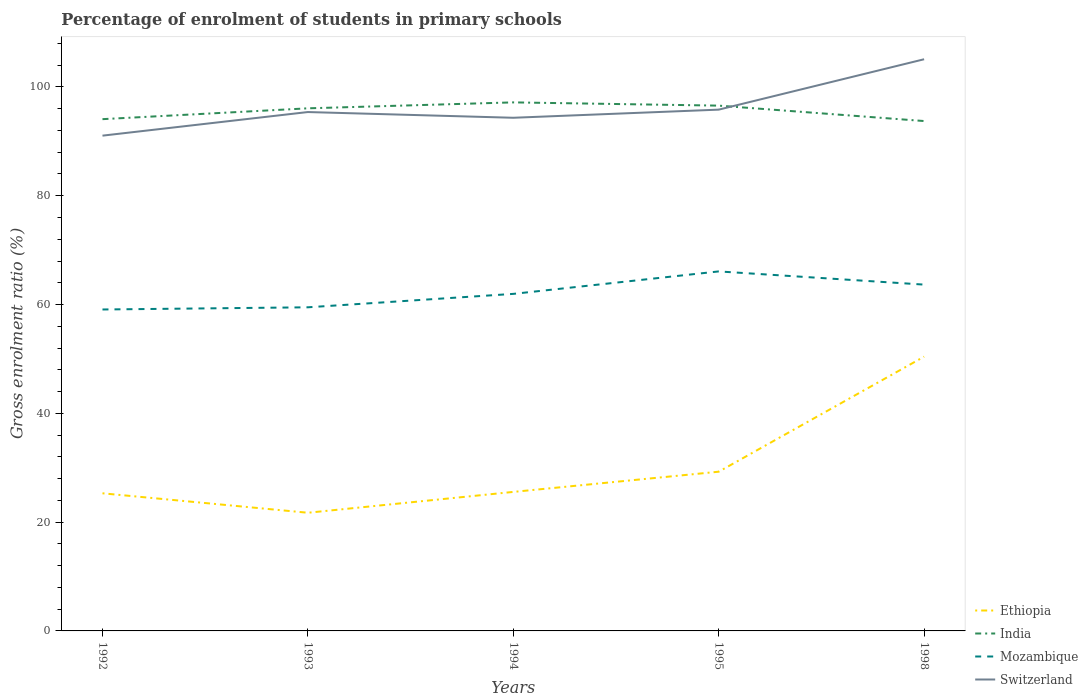How many different coloured lines are there?
Provide a short and direct response. 4. Does the line corresponding to Ethiopia intersect with the line corresponding to Mozambique?
Your response must be concise. No. Across all years, what is the maximum percentage of students enrolled in primary schools in Switzerland?
Offer a very short reply. 91.04. In which year was the percentage of students enrolled in primary schools in Mozambique maximum?
Your response must be concise. 1992. What is the total percentage of students enrolled in primary schools in Mozambique in the graph?
Give a very brief answer. -4.13. What is the difference between the highest and the second highest percentage of students enrolled in primary schools in Mozambique?
Your answer should be compact. 7. How many years are there in the graph?
Your response must be concise. 5. Are the values on the major ticks of Y-axis written in scientific E-notation?
Ensure brevity in your answer.  No. How many legend labels are there?
Your answer should be very brief. 4. How are the legend labels stacked?
Offer a terse response. Vertical. What is the title of the graph?
Your response must be concise. Percentage of enrolment of students in primary schools. Does "Cayman Islands" appear as one of the legend labels in the graph?
Offer a very short reply. No. What is the label or title of the Y-axis?
Provide a short and direct response. Gross enrolment ratio (%). What is the Gross enrolment ratio (%) in Ethiopia in 1992?
Give a very brief answer. 25.3. What is the Gross enrolment ratio (%) in India in 1992?
Give a very brief answer. 94.08. What is the Gross enrolment ratio (%) in Mozambique in 1992?
Keep it short and to the point. 59.09. What is the Gross enrolment ratio (%) in Switzerland in 1992?
Make the answer very short. 91.04. What is the Gross enrolment ratio (%) in Ethiopia in 1993?
Provide a succinct answer. 21.72. What is the Gross enrolment ratio (%) in India in 1993?
Your response must be concise. 96.07. What is the Gross enrolment ratio (%) in Mozambique in 1993?
Your answer should be very brief. 59.49. What is the Gross enrolment ratio (%) in Switzerland in 1993?
Provide a succinct answer. 95.38. What is the Gross enrolment ratio (%) of Ethiopia in 1994?
Provide a short and direct response. 25.55. What is the Gross enrolment ratio (%) of India in 1994?
Make the answer very short. 97.16. What is the Gross enrolment ratio (%) in Mozambique in 1994?
Provide a short and direct response. 61.96. What is the Gross enrolment ratio (%) of Switzerland in 1994?
Provide a succinct answer. 94.33. What is the Gross enrolment ratio (%) of Ethiopia in 1995?
Offer a very short reply. 29.27. What is the Gross enrolment ratio (%) in India in 1995?
Provide a short and direct response. 96.56. What is the Gross enrolment ratio (%) of Mozambique in 1995?
Your answer should be compact. 66.09. What is the Gross enrolment ratio (%) in Switzerland in 1995?
Provide a succinct answer. 95.83. What is the Gross enrolment ratio (%) of Ethiopia in 1998?
Provide a short and direct response. 50.42. What is the Gross enrolment ratio (%) of India in 1998?
Ensure brevity in your answer.  93.73. What is the Gross enrolment ratio (%) in Mozambique in 1998?
Ensure brevity in your answer.  63.66. What is the Gross enrolment ratio (%) of Switzerland in 1998?
Your answer should be compact. 105.09. Across all years, what is the maximum Gross enrolment ratio (%) of Ethiopia?
Your answer should be compact. 50.42. Across all years, what is the maximum Gross enrolment ratio (%) in India?
Give a very brief answer. 97.16. Across all years, what is the maximum Gross enrolment ratio (%) of Mozambique?
Your response must be concise. 66.09. Across all years, what is the maximum Gross enrolment ratio (%) of Switzerland?
Provide a short and direct response. 105.09. Across all years, what is the minimum Gross enrolment ratio (%) in Ethiopia?
Your answer should be compact. 21.72. Across all years, what is the minimum Gross enrolment ratio (%) in India?
Make the answer very short. 93.73. Across all years, what is the minimum Gross enrolment ratio (%) of Mozambique?
Make the answer very short. 59.09. Across all years, what is the minimum Gross enrolment ratio (%) in Switzerland?
Offer a very short reply. 91.04. What is the total Gross enrolment ratio (%) in Ethiopia in the graph?
Ensure brevity in your answer.  152.26. What is the total Gross enrolment ratio (%) of India in the graph?
Keep it short and to the point. 477.59. What is the total Gross enrolment ratio (%) of Mozambique in the graph?
Offer a terse response. 310.28. What is the total Gross enrolment ratio (%) of Switzerland in the graph?
Give a very brief answer. 481.67. What is the difference between the Gross enrolment ratio (%) in Ethiopia in 1992 and that in 1993?
Your response must be concise. 3.58. What is the difference between the Gross enrolment ratio (%) of India in 1992 and that in 1993?
Provide a succinct answer. -1.99. What is the difference between the Gross enrolment ratio (%) in Mozambique in 1992 and that in 1993?
Your answer should be compact. -0.4. What is the difference between the Gross enrolment ratio (%) in Switzerland in 1992 and that in 1993?
Keep it short and to the point. -4.34. What is the difference between the Gross enrolment ratio (%) of Ethiopia in 1992 and that in 1994?
Give a very brief answer. -0.26. What is the difference between the Gross enrolment ratio (%) in India in 1992 and that in 1994?
Keep it short and to the point. -3.08. What is the difference between the Gross enrolment ratio (%) in Mozambique in 1992 and that in 1994?
Provide a succinct answer. -2.87. What is the difference between the Gross enrolment ratio (%) of Switzerland in 1992 and that in 1994?
Make the answer very short. -3.29. What is the difference between the Gross enrolment ratio (%) of Ethiopia in 1992 and that in 1995?
Provide a succinct answer. -3.97. What is the difference between the Gross enrolment ratio (%) in India in 1992 and that in 1995?
Ensure brevity in your answer.  -2.49. What is the difference between the Gross enrolment ratio (%) in Mozambique in 1992 and that in 1995?
Ensure brevity in your answer.  -7. What is the difference between the Gross enrolment ratio (%) in Switzerland in 1992 and that in 1995?
Ensure brevity in your answer.  -4.78. What is the difference between the Gross enrolment ratio (%) of Ethiopia in 1992 and that in 1998?
Ensure brevity in your answer.  -25.12. What is the difference between the Gross enrolment ratio (%) of India in 1992 and that in 1998?
Make the answer very short. 0.35. What is the difference between the Gross enrolment ratio (%) in Mozambique in 1992 and that in 1998?
Ensure brevity in your answer.  -4.57. What is the difference between the Gross enrolment ratio (%) of Switzerland in 1992 and that in 1998?
Your response must be concise. -14.04. What is the difference between the Gross enrolment ratio (%) of Ethiopia in 1993 and that in 1994?
Offer a very short reply. -3.83. What is the difference between the Gross enrolment ratio (%) of India in 1993 and that in 1994?
Offer a very short reply. -1.09. What is the difference between the Gross enrolment ratio (%) in Mozambique in 1993 and that in 1994?
Provide a short and direct response. -2.47. What is the difference between the Gross enrolment ratio (%) of Switzerland in 1993 and that in 1994?
Offer a very short reply. 1.05. What is the difference between the Gross enrolment ratio (%) in Ethiopia in 1993 and that in 1995?
Make the answer very short. -7.55. What is the difference between the Gross enrolment ratio (%) in India in 1993 and that in 1995?
Provide a succinct answer. -0.5. What is the difference between the Gross enrolment ratio (%) of Mozambique in 1993 and that in 1995?
Your response must be concise. -6.6. What is the difference between the Gross enrolment ratio (%) of Switzerland in 1993 and that in 1995?
Offer a very short reply. -0.44. What is the difference between the Gross enrolment ratio (%) of Ethiopia in 1993 and that in 1998?
Provide a short and direct response. -28.7. What is the difference between the Gross enrolment ratio (%) of India in 1993 and that in 1998?
Give a very brief answer. 2.34. What is the difference between the Gross enrolment ratio (%) of Mozambique in 1993 and that in 1998?
Give a very brief answer. -4.17. What is the difference between the Gross enrolment ratio (%) in Switzerland in 1993 and that in 1998?
Ensure brevity in your answer.  -9.7. What is the difference between the Gross enrolment ratio (%) of Ethiopia in 1994 and that in 1995?
Your response must be concise. -3.71. What is the difference between the Gross enrolment ratio (%) in India in 1994 and that in 1995?
Make the answer very short. 0.6. What is the difference between the Gross enrolment ratio (%) in Mozambique in 1994 and that in 1995?
Your answer should be compact. -4.13. What is the difference between the Gross enrolment ratio (%) of Switzerland in 1994 and that in 1995?
Your response must be concise. -1.49. What is the difference between the Gross enrolment ratio (%) in Ethiopia in 1994 and that in 1998?
Keep it short and to the point. -24.86. What is the difference between the Gross enrolment ratio (%) of India in 1994 and that in 1998?
Your answer should be compact. 3.43. What is the difference between the Gross enrolment ratio (%) of Mozambique in 1994 and that in 1998?
Make the answer very short. -1.7. What is the difference between the Gross enrolment ratio (%) of Switzerland in 1994 and that in 1998?
Provide a succinct answer. -10.76. What is the difference between the Gross enrolment ratio (%) of Ethiopia in 1995 and that in 1998?
Provide a short and direct response. -21.15. What is the difference between the Gross enrolment ratio (%) of India in 1995 and that in 1998?
Offer a terse response. 2.83. What is the difference between the Gross enrolment ratio (%) in Mozambique in 1995 and that in 1998?
Your answer should be very brief. 2.43. What is the difference between the Gross enrolment ratio (%) of Switzerland in 1995 and that in 1998?
Ensure brevity in your answer.  -9.26. What is the difference between the Gross enrolment ratio (%) of Ethiopia in 1992 and the Gross enrolment ratio (%) of India in 1993?
Provide a short and direct response. -70.77. What is the difference between the Gross enrolment ratio (%) of Ethiopia in 1992 and the Gross enrolment ratio (%) of Mozambique in 1993?
Provide a succinct answer. -34.19. What is the difference between the Gross enrolment ratio (%) of Ethiopia in 1992 and the Gross enrolment ratio (%) of Switzerland in 1993?
Your answer should be compact. -70.08. What is the difference between the Gross enrolment ratio (%) of India in 1992 and the Gross enrolment ratio (%) of Mozambique in 1993?
Make the answer very short. 34.59. What is the difference between the Gross enrolment ratio (%) of India in 1992 and the Gross enrolment ratio (%) of Switzerland in 1993?
Your answer should be compact. -1.31. What is the difference between the Gross enrolment ratio (%) in Mozambique in 1992 and the Gross enrolment ratio (%) in Switzerland in 1993?
Your answer should be compact. -36.3. What is the difference between the Gross enrolment ratio (%) of Ethiopia in 1992 and the Gross enrolment ratio (%) of India in 1994?
Your response must be concise. -71.86. What is the difference between the Gross enrolment ratio (%) of Ethiopia in 1992 and the Gross enrolment ratio (%) of Mozambique in 1994?
Offer a very short reply. -36.66. What is the difference between the Gross enrolment ratio (%) in Ethiopia in 1992 and the Gross enrolment ratio (%) in Switzerland in 1994?
Provide a short and direct response. -69.03. What is the difference between the Gross enrolment ratio (%) of India in 1992 and the Gross enrolment ratio (%) of Mozambique in 1994?
Your answer should be very brief. 32.12. What is the difference between the Gross enrolment ratio (%) of India in 1992 and the Gross enrolment ratio (%) of Switzerland in 1994?
Give a very brief answer. -0.26. What is the difference between the Gross enrolment ratio (%) of Mozambique in 1992 and the Gross enrolment ratio (%) of Switzerland in 1994?
Offer a terse response. -35.24. What is the difference between the Gross enrolment ratio (%) of Ethiopia in 1992 and the Gross enrolment ratio (%) of India in 1995?
Offer a very short reply. -71.26. What is the difference between the Gross enrolment ratio (%) in Ethiopia in 1992 and the Gross enrolment ratio (%) in Mozambique in 1995?
Offer a very short reply. -40.79. What is the difference between the Gross enrolment ratio (%) of Ethiopia in 1992 and the Gross enrolment ratio (%) of Switzerland in 1995?
Keep it short and to the point. -70.53. What is the difference between the Gross enrolment ratio (%) in India in 1992 and the Gross enrolment ratio (%) in Mozambique in 1995?
Your answer should be very brief. 27.99. What is the difference between the Gross enrolment ratio (%) of India in 1992 and the Gross enrolment ratio (%) of Switzerland in 1995?
Your response must be concise. -1.75. What is the difference between the Gross enrolment ratio (%) of Mozambique in 1992 and the Gross enrolment ratio (%) of Switzerland in 1995?
Your answer should be very brief. -36.74. What is the difference between the Gross enrolment ratio (%) of Ethiopia in 1992 and the Gross enrolment ratio (%) of India in 1998?
Provide a short and direct response. -68.43. What is the difference between the Gross enrolment ratio (%) of Ethiopia in 1992 and the Gross enrolment ratio (%) of Mozambique in 1998?
Give a very brief answer. -38.36. What is the difference between the Gross enrolment ratio (%) in Ethiopia in 1992 and the Gross enrolment ratio (%) in Switzerland in 1998?
Make the answer very short. -79.79. What is the difference between the Gross enrolment ratio (%) in India in 1992 and the Gross enrolment ratio (%) in Mozambique in 1998?
Your response must be concise. 30.42. What is the difference between the Gross enrolment ratio (%) of India in 1992 and the Gross enrolment ratio (%) of Switzerland in 1998?
Give a very brief answer. -11.01. What is the difference between the Gross enrolment ratio (%) in Mozambique in 1992 and the Gross enrolment ratio (%) in Switzerland in 1998?
Provide a short and direct response. -46. What is the difference between the Gross enrolment ratio (%) of Ethiopia in 1993 and the Gross enrolment ratio (%) of India in 1994?
Give a very brief answer. -75.44. What is the difference between the Gross enrolment ratio (%) of Ethiopia in 1993 and the Gross enrolment ratio (%) of Mozambique in 1994?
Provide a succinct answer. -40.23. What is the difference between the Gross enrolment ratio (%) of Ethiopia in 1993 and the Gross enrolment ratio (%) of Switzerland in 1994?
Your response must be concise. -72.61. What is the difference between the Gross enrolment ratio (%) in India in 1993 and the Gross enrolment ratio (%) in Mozambique in 1994?
Your answer should be compact. 34.11. What is the difference between the Gross enrolment ratio (%) of India in 1993 and the Gross enrolment ratio (%) of Switzerland in 1994?
Provide a succinct answer. 1.73. What is the difference between the Gross enrolment ratio (%) of Mozambique in 1993 and the Gross enrolment ratio (%) of Switzerland in 1994?
Offer a terse response. -34.84. What is the difference between the Gross enrolment ratio (%) of Ethiopia in 1993 and the Gross enrolment ratio (%) of India in 1995?
Your answer should be compact. -74.84. What is the difference between the Gross enrolment ratio (%) in Ethiopia in 1993 and the Gross enrolment ratio (%) in Mozambique in 1995?
Ensure brevity in your answer.  -44.36. What is the difference between the Gross enrolment ratio (%) of Ethiopia in 1993 and the Gross enrolment ratio (%) of Switzerland in 1995?
Make the answer very short. -74.1. What is the difference between the Gross enrolment ratio (%) of India in 1993 and the Gross enrolment ratio (%) of Mozambique in 1995?
Provide a succinct answer. 29.98. What is the difference between the Gross enrolment ratio (%) in India in 1993 and the Gross enrolment ratio (%) in Switzerland in 1995?
Keep it short and to the point. 0.24. What is the difference between the Gross enrolment ratio (%) of Mozambique in 1993 and the Gross enrolment ratio (%) of Switzerland in 1995?
Make the answer very short. -36.34. What is the difference between the Gross enrolment ratio (%) of Ethiopia in 1993 and the Gross enrolment ratio (%) of India in 1998?
Provide a short and direct response. -72.01. What is the difference between the Gross enrolment ratio (%) in Ethiopia in 1993 and the Gross enrolment ratio (%) in Mozambique in 1998?
Provide a short and direct response. -41.94. What is the difference between the Gross enrolment ratio (%) in Ethiopia in 1993 and the Gross enrolment ratio (%) in Switzerland in 1998?
Offer a very short reply. -83.37. What is the difference between the Gross enrolment ratio (%) of India in 1993 and the Gross enrolment ratio (%) of Mozambique in 1998?
Offer a very short reply. 32.41. What is the difference between the Gross enrolment ratio (%) in India in 1993 and the Gross enrolment ratio (%) in Switzerland in 1998?
Provide a succinct answer. -9.02. What is the difference between the Gross enrolment ratio (%) of Mozambique in 1993 and the Gross enrolment ratio (%) of Switzerland in 1998?
Your answer should be very brief. -45.6. What is the difference between the Gross enrolment ratio (%) of Ethiopia in 1994 and the Gross enrolment ratio (%) of India in 1995?
Provide a short and direct response. -71.01. What is the difference between the Gross enrolment ratio (%) in Ethiopia in 1994 and the Gross enrolment ratio (%) in Mozambique in 1995?
Make the answer very short. -40.53. What is the difference between the Gross enrolment ratio (%) in Ethiopia in 1994 and the Gross enrolment ratio (%) in Switzerland in 1995?
Keep it short and to the point. -70.27. What is the difference between the Gross enrolment ratio (%) of India in 1994 and the Gross enrolment ratio (%) of Mozambique in 1995?
Provide a short and direct response. 31.07. What is the difference between the Gross enrolment ratio (%) in India in 1994 and the Gross enrolment ratio (%) in Switzerland in 1995?
Give a very brief answer. 1.33. What is the difference between the Gross enrolment ratio (%) of Mozambique in 1994 and the Gross enrolment ratio (%) of Switzerland in 1995?
Give a very brief answer. -33.87. What is the difference between the Gross enrolment ratio (%) in Ethiopia in 1994 and the Gross enrolment ratio (%) in India in 1998?
Give a very brief answer. -68.17. What is the difference between the Gross enrolment ratio (%) of Ethiopia in 1994 and the Gross enrolment ratio (%) of Mozambique in 1998?
Your answer should be very brief. -38.11. What is the difference between the Gross enrolment ratio (%) of Ethiopia in 1994 and the Gross enrolment ratio (%) of Switzerland in 1998?
Offer a terse response. -79.53. What is the difference between the Gross enrolment ratio (%) in India in 1994 and the Gross enrolment ratio (%) in Mozambique in 1998?
Make the answer very short. 33.5. What is the difference between the Gross enrolment ratio (%) in India in 1994 and the Gross enrolment ratio (%) in Switzerland in 1998?
Provide a short and direct response. -7.93. What is the difference between the Gross enrolment ratio (%) in Mozambique in 1994 and the Gross enrolment ratio (%) in Switzerland in 1998?
Provide a short and direct response. -43.13. What is the difference between the Gross enrolment ratio (%) of Ethiopia in 1995 and the Gross enrolment ratio (%) of India in 1998?
Give a very brief answer. -64.46. What is the difference between the Gross enrolment ratio (%) in Ethiopia in 1995 and the Gross enrolment ratio (%) in Mozambique in 1998?
Offer a very short reply. -34.39. What is the difference between the Gross enrolment ratio (%) in Ethiopia in 1995 and the Gross enrolment ratio (%) in Switzerland in 1998?
Provide a succinct answer. -75.82. What is the difference between the Gross enrolment ratio (%) of India in 1995 and the Gross enrolment ratio (%) of Mozambique in 1998?
Keep it short and to the point. 32.9. What is the difference between the Gross enrolment ratio (%) in India in 1995 and the Gross enrolment ratio (%) in Switzerland in 1998?
Ensure brevity in your answer.  -8.53. What is the difference between the Gross enrolment ratio (%) in Mozambique in 1995 and the Gross enrolment ratio (%) in Switzerland in 1998?
Your answer should be very brief. -39. What is the average Gross enrolment ratio (%) of Ethiopia per year?
Make the answer very short. 30.45. What is the average Gross enrolment ratio (%) in India per year?
Your answer should be very brief. 95.52. What is the average Gross enrolment ratio (%) in Mozambique per year?
Your answer should be compact. 62.06. What is the average Gross enrolment ratio (%) in Switzerland per year?
Provide a short and direct response. 96.33. In the year 1992, what is the difference between the Gross enrolment ratio (%) in Ethiopia and Gross enrolment ratio (%) in India?
Offer a terse response. -68.78. In the year 1992, what is the difference between the Gross enrolment ratio (%) of Ethiopia and Gross enrolment ratio (%) of Mozambique?
Your answer should be very brief. -33.79. In the year 1992, what is the difference between the Gross enrolment ratio (%) of Ethiopia and Gross enrolment ratio (%) of Switzerland?
Your response must be concise. -65.74. In the year 1992, what is the difference between the Gross enrolment ratio (%) of India and Gross enrolment ratio (%) of Mozambique?
Give a very brief answer. 34.99. In the year 1992, what is the difference between the Gross enrolment ratio (%) in India and Gross enrolment ratio (%) in Switzerland?
Your answer should be very brief. 3.03. In the year 1992, what is the difference between the Gross enrolment ratio (%) in Mozambique and Gross enrolment ratio (%) in Switzerland?
Ensure brevity in your answer.  -31.96. In the year 1993, what is the difference between the Gross enrolment ratio (%) in Ethiopia and Gross enrolment ratio (%) in India?
Give a very brief answer. -74.34. In the year 1993, what is the difference between the Gross enrolment ratio (%) of Ethiopia and Gross enrolment ratio (%) of Mozambique?
Ensure brevity in your answer.  -37.77. In the year 1993, what is the difference between the Gross enrolment ratio (%) of Ethiopia and Gross enrolment ratio (%) of Switzerland?
Offer a terse response. -73.66. In the year 1993, what is the difference between the Gross enrolment ratio (%) of India and Gross enrolment ratio (%) of Mozambique?
Ensure brevity in your answer.  36.58. In the year 1993, what is the difference between the Gross enrolment ratio (%) in India and Gross enrolment ratio (%) in Switzerland?
Offer a terse response. 0.68. In the year 1993, what is the difference between the Gross enrolment ratio (%) in Mozambique and Gross enrolment ratio (%) in Switzerland?
Provide a succinct answer. -35.89. In the year 1994, what is the difference between the Gross enrolment ratio (%) in Ethiopia and Gross enrolment ratio (%) in India?
Your answer should be compact. -71.6. In the year 1994, what is the difference between the Gross enrolment ratio (%) in Ethiopia and Gross enrolment ratio (%) in Mozambique?
Ensure brevity in your answer.  -36.4. In the year 1994, what is the difference between the Gross enrolment ratio (%) of Ethiopia and Gross enrolment ratio (%) of Switzerland?
Provide a succinct answer. -68.78. In the year 1994, what is the difference between the Gross enrolment ratio (%) in India and Gross enrolment ratio (%) in Mozambique?
Your answer should be compact. 35.2. In the year 1994, what is the difference between the Gross enrolment ratio (%) in India and Gross enrolment ratio (%) in Switzerland?
Your answer should be compact. 2.83. In the year 1994, what is the difference between the Gross enrolment ratio (%) in Mozambique and Gross enrolment ratio (%) in Switzerland?
Your response must be concise. -32.37. In the year 1995, what is the difference between the Gross enrolment ratio (%) in Ethiopia and Gross enrolment ratio (%) in India?
Your response must be concise. -67.29. In the year 1995, what is the difference between the Gross enrolment ratio (%) in Ethiopia and Gross enrolment ratio (%) in Mozambique?
Provide a succinct answer. -36.82. In the year 1995, what is the difference between the Gross enrolment ratio (%) of Ethiopia and Gross enrolment ratio (%) of Switzerland?
Make the answer very short. -66.56. In the year 1995, what is the difference between the Gross enrolment ratio (%) of India and Gross enrolment ratio (%) of Mozambique?
Offer a very short reply. 30.48. In the year 1995, what is the difference between the Gross enrolment ratio (%) of India and Gross enrolment ratio (%) of Switzerland?
Ensure brevity in your answer.  0.74. In the year 1995, what is the difference between the Gross enrolment ratio (%) of Mozambique and Gross enrolment ratio (%) of Switzerland?
Make the answer very short. -29.74. In the year 1998, what is the difference between the Gross enrolment ratio (%) of Ethiopia and Gross enrolment ratio (%) of India?
Keep it short and to the point. -43.31. In the year 1998, what is the difference between the Gross enrolment ratio (%) of Ethiopia and Gross enrolment ratio (%) of Mozambique?
Provide a short and direct response. -13.24. In the year 1998, what is the difference between the Gross enrolment ratio (%) in Ethiopia and Gross enrolment ratio (%) in Switzerland?
Your answer should be very brief. -54.67. In the year 1998, what is the difference between the Gross enrolment ratio (%) of India and Gross enrolment ratio (%) of Mozambique?
Offer a very short reply. 30.07. In the year 1998, what is the difference between the Gross enrolment ratio (%) in India and Gross enrolment ratio (%) in Switzerland?
Your response must be concise. -11.36. In the year 1998, what is the difference between the Gross enrolment ratio (%) in Mozambique and Gross enrolment ratio (%) in Switzerland?
Your answer should be very brief. -41.43. What is the ratio of the Gross enrolment ratio (%) in Ethiopia in 1992 to that in 1993?
Offer a terse response. 1.16. What is the ratio of the Gross enrolment ratio (%) of India in 1992 to that in 1993?
Give a very brief answer. 0.98. What is the ratio of the Gross enrolment ratio (%) of Switzerland in 1992 to that in 1993?
Ensure brevity in your answer.  0.95. What is the ratio of the Gross enrolment ratio (%) in India in 1992 to that in 1994?
Offer a terse response. 0.97. What is the ratio of the Gross enrolment ratio (%) of Mozambique in 1992 to that in 1994?
Provide a short and direct response. 0.95. What is the ratio of the Gross enrolment ratio (%) in Switzerland in 1992 to that in 1994?
Your response must be concise. 0.97. What is the ratio of the Gross enrolment ratio (%) of Ethiopia in 1992 to that in 1995?
Keep it short and to the point. 0.86. What is the ratio of the Gross enrolment ratio (%) in India in 1992 to that in 1995?
Your response must be concise. 0.97. What is the ratio of the Gross enrolment ratio (%) in Mozambique in 1992 to that in 1995?
Keep it short and to the point. 0.89. What is the ratio of the Gross enrolment ratio (%) in Switzerland in 1992 to that in 1995?
Ensure brevity in your answer.  0.95. What is the ratio of the Gross enrolment ratio (%) in Ethiopia in 1992 to that in 1998?
Provide a short and direct response. 0.5. What is the ratio of the Gross enrolment ratio (%) of Mozambique in 1992 to that in 1998?
Your answer should be very brief. 0.93. What is the ratio of the Gross enrolment ratio (%) in Switzerland in 1992 to that in 1998?
Your answer should be very brief. 0.87. What is the ratio of the Gross enrolment ratio (%) in Ethiopia in 1993 to that in 1994?
Provide a short and direct response. 0.85. What is the ratio of the Gross enrolment ratio (%) of Mozambique in 1993 to that in 1994?
Your answer should be compact. 0.96. What is the ratio of the Gross enrolment ratio (%) of Switzerland in 1993 to that in 1994?
Make the answer very short. 1.01. What is the ratio of the Gross enrolment ratio (%) of Ethiopia in 1993 to that in 1995?
Your answer should be very brief. 0.74. What is the ratio of the Gross enrolment ratio (%) in India in 1993 to that in 1995?
Ensure brevity in your answer.  0.99. What is the ratio of the Gross enrolment ratio (%) in Mozambique in 1993 to that in 1995?
Offer a terse response. 0.9. What is the ratio of the Gross enrolment ratio (%) of Switzerland in 1993 to that in 1995?
Offer a terse response. 1. What is the ratio of the Gross enrolment ratio (%) in Ethiopia in 1993 to that in 1998?
Your answer should be compact. 0.43. What is the ratio of the Gross enrolment ratio (%) in India in 1993 to that in 1998?
Your response must be concise. 1.02. What is the ratio of the Gross enrolment ratio (%) of Mozambique in 1993 to that in 1998?
Your answer should be very brief. 0.93. What is the ratio of the Gross enrolment ratio (%) of Switzerland in 1993 to that in 1998?
Provide a succinct answer. 0.91. What is the ratio of the Gross enrolment ratio (%) of Ethiopia in 1994 to that in 1995?
Offer a very short reply. 0.87. What is the ratio of the Gross enrolment ratio (%) in India in 1994 to that in 1995?
Make the answer very short. 1.01. What is the ratio of the Gross enrolment ratio (%) of Switzerland in 1994 to that in 1995?
Give a very brief answer. 0.98. What is the ratio of the Gross enrolment ratio (%) in Ethiopia in 1994 to that in 1998?
Offer a very short reply. 0.51. What is the ratio of the Gross enrolment ratio (%) of India in 1994 to that in 1998?
Provide a succinct answer. 1.04. What is the ratio of the Gross enrolment ratio (%) in Mozambique in 1994 to that in 1998?
Give a very brief answer. 0.97. What is the ratio of the Gross enrolment ratio (%) of Switzerland in 1994 to that in 1998?
Give a very brief answer. 0.9. What is the ratio of the Gross enrolment ratio (%) of Ethiopia in 1995 to that in 1998?
Provide a succinct answer. 0.58. What is the ratio of the Gross enrolment ratio (%) in India in 1995 to that in 1998?
Your answer should be compact. 1.03. What is the ratio of the Gross enrolment ratio (%) in Mozambique in 1995 to that in 1998?
Keep it short and to the point. 1.04. What is the ratio of the Gross enrolment ratio (%) of Switzerland in 1995 to that in 1998?
Offer a terse response. 0.91. What is the difference between the highest and the second highest Gross enrolment ratio (%) of Ethiopia?
Ensure brevity in your answer.  21.15. What is the difference between the highest and the second highest Gross enrolment ratio (%) in India?
Give a very brief answer. 0.6. What is the difference between the highest and the second highest Gross enrolment ratio (%) of Mozambique?
Make the answer very short. 2.43. What is the difference between the highest and the second highest Gross enrolment ratio (%) in Switzerland?
Provide a short and direct response. 9.26. What is the difference between the highest and the lowest Gross enrolment ratio (%) of Ethiopia?
Offer a very short reply. 28.7. What is the difference between the highest and the lowest Gross enrolment ratio (%) in India?
Your answer should be very brief. 3.43. What is the difference between the highest and the lowest Gross enrolment ratio (%) of Mozambique?
Your answer should be compact. 7. What is the difference between the highest and the lowest Gross enrolment ratio (%) in Switzerland?
Your response must be concise. 14.04. 